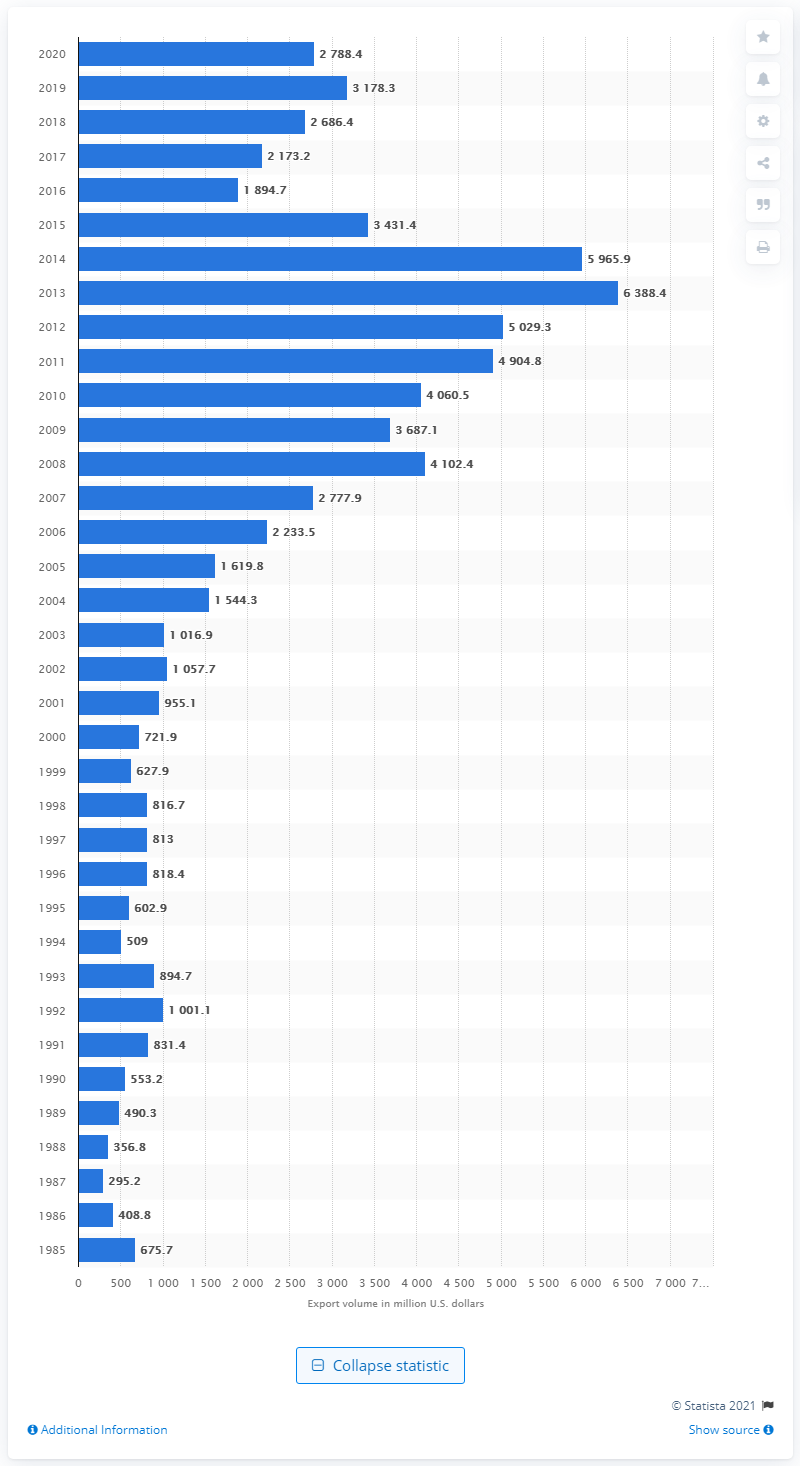Outline some significant characteristics in this image. In 2020, the value of U.S. exports to Nigeria was $2788.4 million. 